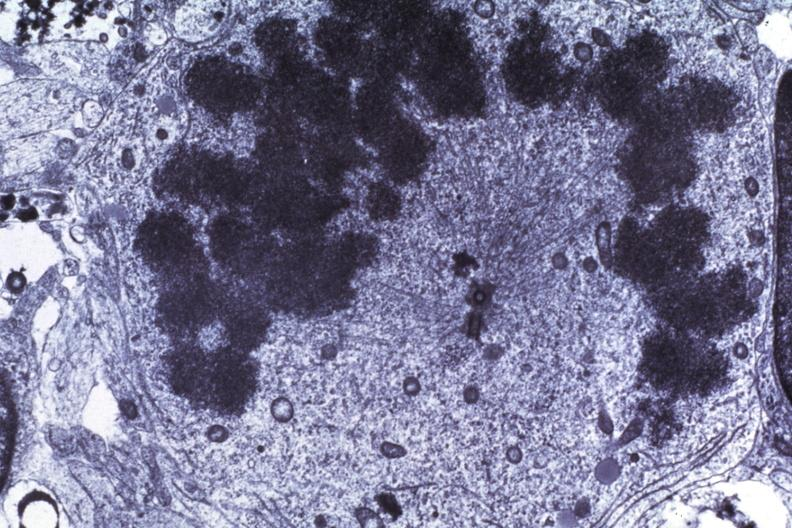does this image show dr garcia tumors 65?
Answer the question using a single word or phrase. Yes 